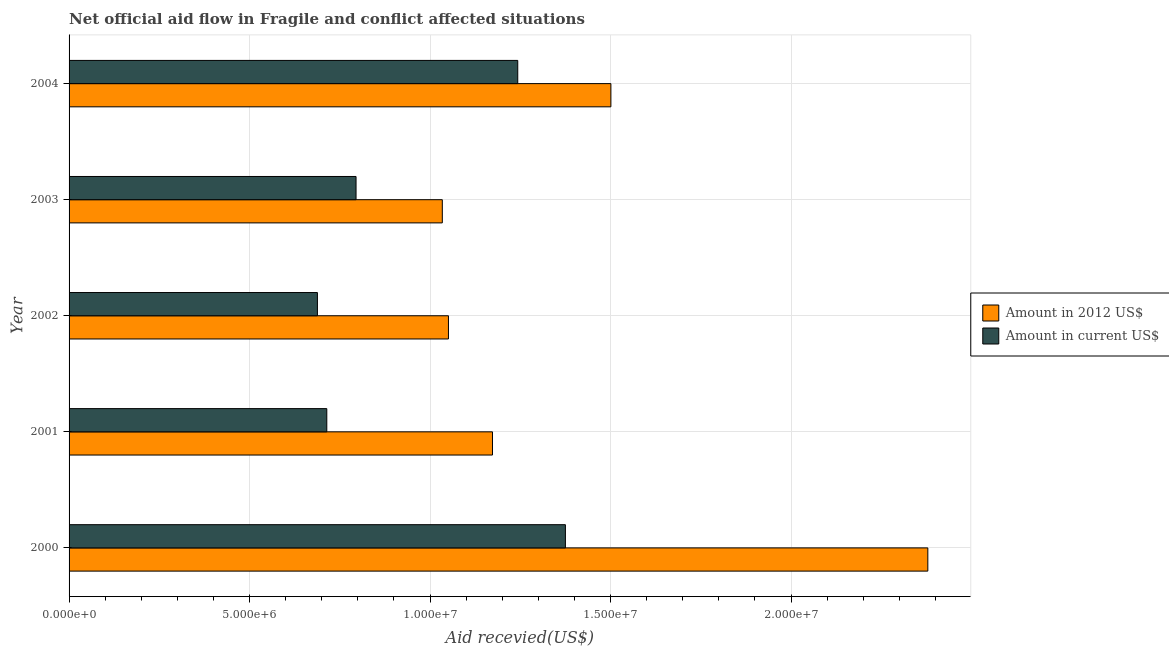How many different coloured bars are there?
Give a very brief answer. 2. How many groups of bars are there?
Provide a succinct answer. 5. Are the number of bars per tick equal to the number of legend labels?
Make the answer very short. Yes. Are the number of bars on each tick of the Y-axis equal?
Give a very brief answer. Yes. How many bars are there on the 4th tick from the bottom?
Offer a terse response. 2. In how many cases, is the number of bars for a given year not equal to the number of legend labels?
Your answer should be very brief. 0. What is the amount of aid received(expressed in us$) in 2001?
Give a very brief answer. 7.14e+06. Across all years, what is the maximum amount of aid received(expressed in 2012 us$)?
Your answer should be very brief. 2.38e+07. Across all years, what is the minimum amount of aid received(expressed in 2012 us$)?
Your answer should be very brief. 1.03e+07. What is the total amount of aid received(expressed in us$) in the graph?
Provide a succinct answer. 4.82e+07. What is the difference between the amount of aid received(expressed in us$) in 2001 and that in 2004?
Offer a very short reply. -5.29e+06. What is the difference between the amount of aid received(expressed in us$) in 2000 and the amount of aid received(expressed in 2012 us$) in 2001?
Ensure brevity in your answer.  2.02e+06. What is the average amount of aid received(expressed in 2012 us$) per year?
Your answer should be compact. 1.43e+07. In the year 2001, what is the difference between the amount of aid received(expressed in 2012 us$) and amount of aid received(expressed in us$)?
Make the answer very short. 4.59e+06. In how many years, is the amount of aid received(expressed in 2012 us$) greater than 18000000 US$?
Make the answer very short. 1. What is the ratio of the amount of aid received(expressed in us$) in 2000 to that in 2002?
Your response must be concise. 2. Is the amount of aid received(expressed in us$) in 2002 less than that in 2004?
Give a very brief answer. Yes. What is the difference between the highest and the second highest amount of aid received(expressed in us$)?
Your answer should be compact. 1.32e+06. What is the difference between the highest and the lowest amount of aid received(expressed in us$)?
Provide a succinct answer. 6.87e+06. Is the sum of the amount of aid received(expressed in 2012 us$) in 2001 and 2002 greater than the maximum amount of aid received(expressed in us$) across all years?
Your answer should be compact. Yes. What does the 1st bar from the top in 2004 represents?
Your answer should be compact. Amount in current US$. What does the 2nd bar from the bottom in 2002 represents?
Keep it short and to the point. Amount in current US$. What is the difference between two consecutive major ticks on the X-axis?
Offer a very short reply. 5.00e+06. Does the graph contain any zero values?
Ensure brevity in your answer.  No. How many legend labels are there?
Provide a succinct answer. 2. What is the title of the graph?
Make the answer very short. Net official aid flow in Fragile and conflict affected situations. What is the label or title of the X-axis?
Provide a succinct answer. Aid recevied(US$). What is the label or title of the Y-axis?
Your answer should be very brief. Year. What is the Aid recevied(US$) of Amount in 2012 US$ in 2000?
Make the answer very short. 2.38e+07. What is the Aid recevied(US$) in Amount in current US$ in 2000?
Keep it short and to the point. 1.38e+07. What is the Aid recevied(US$) of Amount in 2012 US$ in 2001?
Ensure brevity in your answer.  1.17e+07. What is the Aid recevied(US$) in Amount in current US$ in 2001?
Your answer should be compact. 7.14e+06. What is the Aid recevied(US$) in Amount in 2012 US$ in 2002?
Ensure brevity in your answer.  1.05e+07. What is the Aid recevied(US$) in Amount in current US$ in 2002?
Give a very brief answer. 6.88e+06. What is the Aid recevied(US$) in Amount in 2012 US$ in 2003?
Your answer should be compact. 1.03e+07. What is the Aid recevied(US$) of Amount in current US$ in 2003?
Ensure brevity in your answer.  7.95e+06. What is the Aid recevied(US$) of Amount in 2012 US$ in 2004?
Give a very brief answer. 1.50e+07. What is the Aid recevied(US$) in Amount in current US$ in 2004?
Your answer should be compact. 1.24e+07. Across all years, what is the maximum Aid recevied(US$) in Amount in 2012 US$?
Offer a very short reply. 2.38e+07. Across all years, what is the maximum Aid recevied(US$) of Amount in current US$?
Your answer should be very brief. 1.38e+07. Across all years, what is the minimum Aid recevied(US$) of Amount in 2012 US$?
Offer a very short reply. 1.03e+07. Across all years, what is the minimum Aid recevied(US$) of Amount in current US$?
Give a very brief answer. 6.88e+06. What is the total Aid recevied(US$) in Amount in 2012 US$ in the graph?
Ensure brevity in your answer.  7.14e+07. What is the total Aid recevied(US$) of Amount in current US$ in the graph?
Your answer should be compact. 4.82e+07. What is the difference between the Aid recevied(US$) of Amount in 2012 US$ in 2000 and that in 2001?
Your response must be concise. 1.21e+07. What is the difference between the Aid recevied(US$) of Amount in current US$ in 2000 and that in 2001?
Make the answer very short. 6.61e+06. What is the difference between the Aid recevied(US$) of Amount in 2012 US$ in 2000 and that in 2002?
Offer a terse response. 1.33e+07. What is the difference between the Aid recevied(US$) in Amount in current US$ in 2000 and that in 2002?
Your response must be concise. 6.87e+06. What is the difference between the Aid recevied(US$) of Amount in 2012 US$ in 2000 and that in 2003?
Your answer should be very brief. 1.34e+07. What is the difference between the Aid recevied(US$) in Amount in current US$ in 2000 and that in 2003?
Ensure brevity in your answer.  5.80e+06. What is the difference between the Aid recevied(US$) of Amount in 2012 US$ in 2000 and that in 2004?
Provide a short and direct response. 8.78e+06. What is the difference between the Aid recevied(US$) of Amount in current US$ in 2000 and that in 2004?
Keep it short and to the point. 1.32e+06. What is the difference between the Aid recevied(US$) of Amount in 2012 US$ in 2001 and that in 2002?
Your response must be concise. 1.22e+06. What is the difference between the Aid recevied(US$) in Amount in 2012 US$ in 2001 and that in 2003?
Provide a succinct answer. 1.39e+06. What is the difference between the Aid recevied(US$) of Amount in current US$ in 2001 and that in 2003?
Offer a terse response. -8.10e+05. What is the difference between the Aid recevied(US$) of Amount in 2012 US$ in 2001 and that in 2004?
Keep it short and to the point. -3.28e+06. What is the difference between the Aid recevied(US$) in Amount in current US$ in 2001 and that in 2004?
Keep it short and to the point. -5.29e+06. What is the difference between the Aid recevied(US$) in Amount in current US$ in 2002 and that in 2003?
Your answer should be very brief. -1.07e+06. What is the difference between the Aid recevied(US$) in Amount in 2012 US$ in 2002 and that in 2004?
Offer a terse response. -4.50e+06. What is the difference between the Aid recevied(US$) in Amount in current US$ in 2002 and that in 2004?
Ensure brevity in your answer.  -5.55e+06. What is the difference between the Aid recevied(US$) in Amount in 2012 US$ in 2003 and that in 2004?
Keep it short and to the point. -4.67e+06. What is the difference between the Aid recevied(US$) of Amount in current US$ in 2003 and that in 2004?
Your answer should be compact. -4.48e+06. What is the difference between the Aid recevied(US$) in Amount in 2012 US$ in 2000 and the Aid recevied(US$) in Amount in current US$ in 2001?
Your answer should be compact. 1.66e+07. What is the difference between the Aid recevied(US$) in Amount in 2012 US$ in 2000 and the Aid recevied(US$) in Amount in current US$ in 2002?
Keep it short and to the point. 1.69e+07. What is the difference between the Aid recevied(US$) of Amount in 2012 US$ in 2000 and the Aid recevied(US$) of Amount in current US$ in 2003?
Give a very brief answer. 1.58e+07. What is the difference between the Aid recevied(US$) in Amount in 2012 US$ in 2000 and the Aid recevied(US$) in Amount in current US$ in 2004?
Offer a very short reply. 1.14e+07. What is the difference between the Aid recevied(US$) of Amount in 2012 US$ in 2001 and the Aid recevied(US$) of Amount in current US$ in 2002?
Offer a very short reply. 4.85e+06. What is the difference between the Aid recevied(US$) in Amount in 2012 US$ in 2001 and the Aid recevied(US$) in Amount in current US$ in 2003?
Offer a very short reply. 3.78e+06. What is the difference between the Aid recevied(US$) of Amount in 2012 US$ in 2001 and the Aid recevied(US$) of Amount in current US$ in 2004?
Your answer should be compact. -7.00e+05. What is the difference between the Aid recevied(US$) of Amount in 2012 US$ in 2002 and the Aid recevied(US$) of Amount in current US$ in 2003?
Your answer should be compact. 2.56e+06. What is the difference between the Aid recevied(US$) in Amount in 2012 US$ in 2002 and the Aid recevied(US$) in Amount in current US$ in 2004?
Provide a short and direct response. -1.92e+06. What is the difference between the Aid recevied(US$) in Amount in 2012 US$ in 2003 and the Aid recevied(US$) in Amount in current US$ in 2004?
Offer a very short reply. -2.09e+06. What is the average Aid recevied(US$) of Amount in 2012 US$ per year?
Give a very brief answer. 1.43e+07. What is the average Aid recevied(US$) of Amount in current US$ per year?
Ensure brevity in your answer.  9.63e+06. In the year 2000, what is the difference between the Aid recevied(US$) in Amount in 2012 US$ and Aid recevied(US$) in Amount in current US$?
Offer a terse response. 1.00e+07. In the year 2001, what is the difference between the Aid recevied(US$) in Amount in 2012 US$ and Aid recevied(US$) in Amount in current US$?
Make the answer very short. 4.59e+06. In the year 2002, what is the difference between the Aid recevied(US$) of Amount in 2012 US$ and Aid recevied(US$) of Amount in current US$?
Keep it short and to the point. 3.63e+06. In the year 2003, what is the difference between the Aid recevied(US$) in Amount in 2012 US$ and Aid recevied(US$) in Amount in current US$?
Your response must be concise. 2.39e+06. In the year 2004, what is the difference between the Aid recevied(US$) of Amount in 2012 US$ and Aid recevied(US$) of Amount in current US$?
Ensure brevity in your answer.  2.58e+06. What is the ratio of the Aid recevied(US$) in Amount in 2012 US$ in 2000 to that in 2001?
Ensure brevity in your answer.  2.03. What is the ratio of the Aid recevied(US$) of Amount in current US$ in 2000 to that in 2001?
Keep it short and to the point. 1.93. What is the ratio of the Aid recevied(US$) in Amount in 2012 US$ in 2000 to that in 2002?
Provide a succinct answer. 2.26. What is the ratio of the Aid recevied(US$) in Amount in current US$ in 2000 to that in 2002?
Ensure brevity in your answer.  2. What is the ratio of the Aid recevied(US$) in Amount in 2012 US$ in 2000 to that in 2003?
Make the answer very short. 2.3. What is the ratio of the Aid recevied(US$) of Amount in current US$ in 2000 to that in 2003?
Ensure brevity in your answer.  1.73. What is the ratio of the Aid recevied(US$) in Amount in 2012 US$ in 2000 to that in 2004?
Your answer should be very brief. 1.58. What is the ratio of the Aid recevied(US$) of Amount in current US$ in 2000 to that in 2004?
Give a very brief answer. 1.11. What is the ratio of the Aid recevied(US$) of Amount in 2012 US$ in 2001 to that in 2002?
Your answer should be very brief. 1.12. What is the ratio of the Aid recevied(US$) in Amount in current US$ in 2001 to that in 2002?
Provide a short and direct response. 1.04. What is the ratio of the Aid recevied(US$) in Amount in 2012 US$ in 2001 to that in 2003?
Offer a terse response. 1.13. What is the ratio of the Aid recevied(US$) of Amount in current US$ in 2001 to that in 2003?
Provide a short and direct response. 0.9. What is the ratio of the Aid recevied(US$) in Amount in 2012 US$ in 2001 to that in 2004?
Your answer should be very brief. 0.78. What is the ratio of the Aid recevied(US$) in Amount in current US$ in 2001 to that in 2004?
Provide a short and direct response. 0.57. What is the ratio of the Aid recevied(US$) of Amount in 2012 US$ in 2002 to that in 2003?
Your answer should be very brief. 1.02. What is the ratio of the Aid recevied(US$) in Amount in current US$ in 2002 to that in 2003?
Give a very brief answer. 0.87. What is the ratio of the Aid recevied(US$) in Amount in 2012 US$ in 2002 to that in 2004?
Make the answer very short. 0.7. What is the ratio of the Aid recevied(US$) in Amount in current US$ in 2002 to that in 2004?
Offer a very short reply. 0.55. What is the ratio of the Aid recevied(US$) in Amount in 2012 US$ in 2003 to that in 2004?
Make the answer very short. 0.69. What is the ratio of the Aid recevied(US$) of Amount in current US$ in 2003 to that in 2004?
Provide a short and direct response. 0.64. What is the difference between the highest and the second highest Aid recevied(US$) of Amount in 2012 US$?
Ensure brevity in your answer.  8.78e+06. What is the difference between the highest and the second highest Aid recevied(US$) of Amount in current US$?
Your answer should be very brief. 1.32e+06. What is the difference between the highest and the lowest Aid recevied(US$) in Amount in 2012 US$?
Your response must be concise. 1.34e+07. What is the difference between the highest and the lowest Aid recevied(US$) of Amount in current US$?
Give a very brief answer. 6.87e+06. 